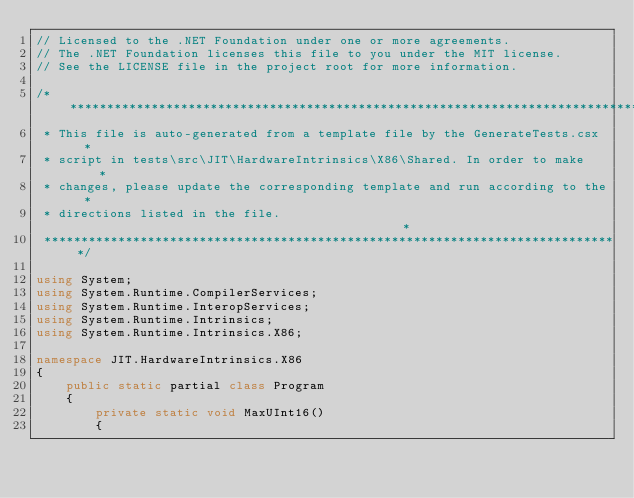<code> <loc_0><loc_0><loc_500><loc_500><_C#_>// Licensed to the .NET Foundation under one or more agreements.
// The .NET Foundation licenses this file to you under the MIT license.
// See the LICENSE file in the project root for more information.

/******************************************************************************
 * This file is auto-generated from a template file by the GenerateTests.csx  *
 * script in tests\src\JIT\HardwareIntrinsics\X86\Shared. In order to make    *
 * changes, please update the corresponding template and run according to the *
 * directions listed in the file.                                             *
 ******************************************************************************/

using System;
using System.Runtime.CompilerServices;
using System.Runtime.InteropServices;
using System.Runtime.Intrinsics;
using System.Runtime.Intrinsics.X86;

namespace JIT.HardwareIntrinsics.X86
{
    public static partial class Program
    {
        private static void MaxUInt16()
        {</code> 